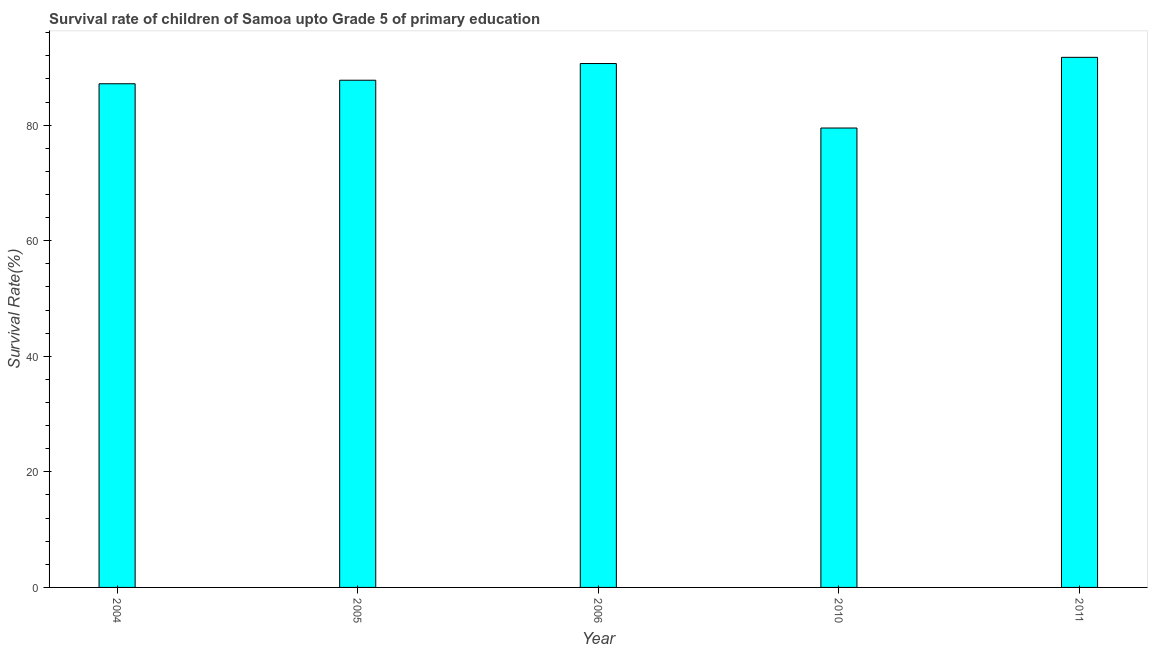Does the graph contain any zero values?
Provide a succinct answer. No. Does the graph contain grids?
Your answer should be very brief. No. What is the title of the graph?
Give a very brief answer. Survival rate of children of Samoa upto Grade 5 of primary education. What is the label or title of the Y-axis?
Offer a terse response. Survival Rate(%). What is the survival rate in 2006?
Your response must be concise. 90.66. Across all years, what is the maximum survival rate?
Keep it short and to the point. 91.74. Across all years, what is the minimum survival rate?
Your answer should be compact. 79.5. In which year was the survival rate maximum?
Your answer should be compact. 2011. What is the sum of the survival rate?
Keep it short and to the point. 436.85. What is the difference between the survival rate in 2004 and 2010?
Offer a terse response. 7.66. What is the average survival rate per year?
Keep it short and to the point. 87.37. What is the median survival rate?
Your answer should be compact. 87.78. In how many years, is the survival rate greater than 84 %?
Your response must be concise. 4. Do a majority of the years between 2011 and 2010 (inclusive) have survival rate greater than 48 %?
Provide a short and direct response. No. What is the ratio of the survival rate in 2005 to that in 2006?
Offer a terse response. 0.97. Is the survival rate in 2006 less than that in 2010?
Provide a succinct answer. No. What is the difference between the highest and the second highest survival rate?
Provide a short and direct response. 1.07. What is the difference between the highest and the lowest survival rate?
Provide a succinct answer. 12.23. In how many years, is the survival rate greater than the average survival rate taken over all years?
Your answer should be compact. 3. How many bars are there?
Make the answer very short. 5. Are all the bars in the graph horizontal?
Offer a very short reply. No. What is the Survival Rate(%) of 2004?
Make the answer very short. 87.17. What is the Survival Rate(%) in 2005?
Make the answer very short. 87.78. What is the Survival Rate(%) of 2006?
Your answer should be very brief. 90.66. What is the Survival Rate(%) of 2010?
Your response must be concise. 79.5. What is the Survival Rate(%) in 2011?
Your answer should be compact. 91.74. What is the difference between the Survival Rate(%) in 2004 and 2005?
Give a very brief answer. -0.61. What is the difference between the Survival Rate(%) in 2004 and 2006?
Your answer should be very brief. -3.5. What is the difference between the Survival Rate(%) in 2004 and 2010?
Your response must be concise. 7.66. What is the difference between the Survival Rate(%) in 2004 and 2011?
Your answer should be compact. -4.57. What is the difference between the Survival Rate(%) in 2005 and 2006?
Provide a short and direct response. -2.89. What is the difference between the Survival Rate(%) in 2005 and 2010?
Provide a succinct answer. 8.27. What is the difference between the Survival Rate(%) in 2005 and 2011?
Offer a terse response. -3.96. What is the difference between the Survival Rate(%) in 2006 and 2010?
Offer a very short reply. 11.16. What is the difference between the Survival Rate(%) in 2006 and 2011?
Provide a short and direct response. -1.07. What is the difference between the Survival Rate(%) in 2010 and 2011?
Your response must be concise. -12.23. What is the ratio of the Survival Rate(%) in 2004 to that in 2006?
Give a very brief answer. 0.96. What is the ratio of the Survival Rate(%) in 2004 to that in 2010?
Give a very brief answer. 1.1. What is the ratio of the Survival Rate(%) in 2004 to that in 2011?
Provide a short and direct response. 0.95. What is the ratio of the Survival Rate(%) in 2005 to that in 2006?
Your response must be concise. 0.97. What is the ratio of the Survival Rate(%) in 2005 to that in 2010?
Offer a very short reply. 1.1. What is the ratio of the Survival Rate(%) in 2005 to that in 2011?
Provide a short and direct response. 0.96. What is the ratio of the Survival Rate(%) in 2006 to that in 2010?
Ensure brevity in your answer.  1.14. What is the ratio of the Survival Rate(%) in 2006 to that in 2011?
Provide a succinct answer. 0.99. What is the ratio of the Survival Rate(%) in 2010 to that in 2011?
Provide a short and direct response. 0.87. 